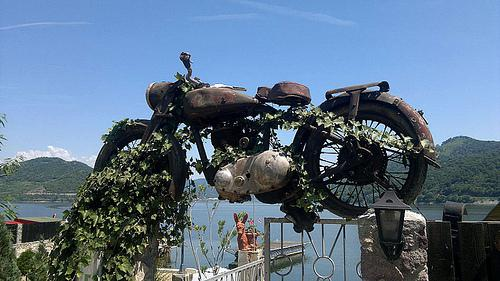Question: why is the motorcycle rusted?
Choices:
A. It is an antique.
B. It is outside.
C. Because it's old.
D. It was smashed.
Answer with the letter. Answer: C Question: what is growing on the motorcycle?
Choices:
A. Vines.
B. Plants.
C. Grass.
D. Moss.
Answer with the letter. Answer: A Question: what color are the wheels?
Choices:
A. Brown.
B. Red.
C. Black.
D. Silver.
Answer with the letter. Answer: C 